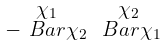<formula> <loc_0><loc_0><loc_500><loc_500>\begin{smallmatrix} \chi _ { 1 } & \chi _ { 2 } \\ - \ B a r { \chi } _ { 2 } & \ B a r { \chi } _ { 1 } \end{smallmatrix}</formula> 